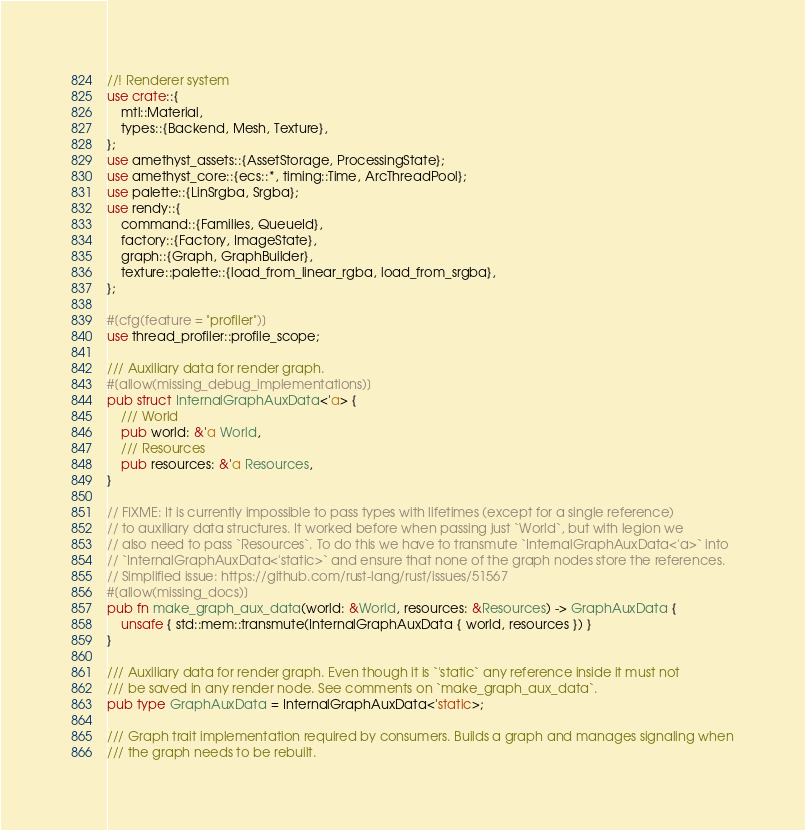<code> <loc_0><loc_0><loc_500><loc_500><_Rust_>//! Renderer system
use crate::{
    mtl::Material,
    types::{Backend, Mesh, Texture},
};
use amethyst_assets::{AssetStorage, ProcessingState};
use amethyst_core::{ecs::*, timing::Time, ArcThreadPool};
use palette::{LinSrgba, Srgba};
use rendy::{
    command::{Families, QueueId},
    factory::{Factory, ImageState},
    graph::{Graph, GraphBuilder},
    texture::palette::{load_from_linear_rgba, load_from_srgba},
};

#[cfg(feature = "profiler")]
use thread_profiler::profile_scope;

/// Auxiliary data for render graph.
#[allow(missing_debug_implementations)]
pub struct InternalGraphAuxData<'a> {
    /// World
    pub world: &'a World,
    /// Resources
    pub resources: &'a Resources,
}

// FIXME: It is currently impossible to pass types with lifetimes (except for a single reference)
// to auxiliary data structures. It worked before when passing just `World`, but with legion we
// also need to pass `Resources`. To do this we have to transmute `InternalGraphAuxData<'a>` into
// `InternalGraphAuxData<'static>` and ensure that none of the graph nodes store the references.
// Simplified issue: https://github.com/rust-lang/rust/issues/51567
#[allow(missing_docs)]
pub fn make_graph_aux_data(world: &World, resources: &Resources) -> GraphAuxData {
    unsafe { std::mem::transmute(InternalGraphAuxData { world, resources }) }
}

/// Auxiliary data for render graph. Even though it is `'static` any reference inside it must not
/// be saved in any render node. See comments on `make_graph_aux_data`.
pub type GraphAuxData = InternalGraphAuxData<'static>;

/// Graph trait implementation required by consumers. Builds a graph and manages signaling when
/// the graph needs to be rebuilt.</code> 